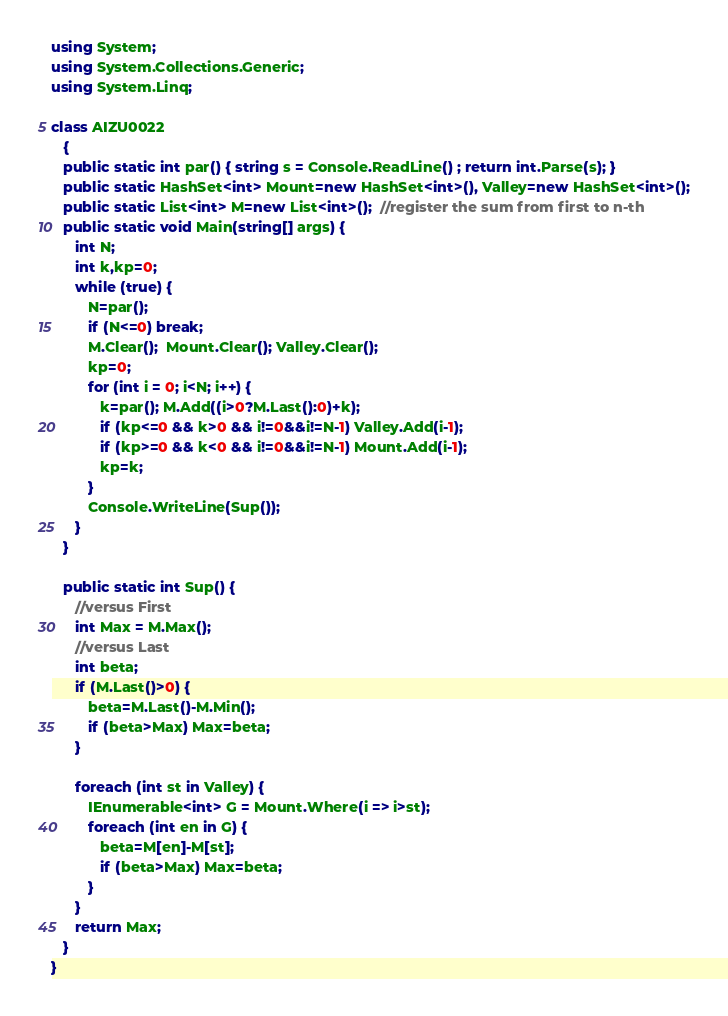<code> <loc_0><loc_0><loc_500><loc_500><_C#_>using System;
using System.Collections.Generic;
using System.Linq;

class AIZU0022
   {
   public static int par() { string s = Console.ReadLine() ; return int.Parse(s); }
   public static HashSet<int> Mount=new HashSet<int>(), Valley=new HashSet<int>();
   public static List<int> M=new List<int>();  //register the sum from first to n-th
   public static void Main(string[] args) {
      int N;
      int k,kp=0;
      while (true) {
         N=par();
         if (N<=0) break;
         M.Clear();  Mount.Clear(); Valley.Clear();
         kp=0;
         for (int i = 0; i<N; i++) {
            k=par(); M.Add((i>0?M.Last():0)+k);
            if (kp<=0 && k>0 && i!=0&&i!=N-1) Valley.Add(i-1);
            if (kp>=0 && k<0 && i!=0&&i!=N-1) Mount.Add(i-1);
            kp=k;
         }
         Console.WriteLine(Sup());
      }
   }

   public static int Sup() { 
      //versus First
      int Max = M.Max();
      //versus Last
      int beta;
      if (M.Last()>0) {
         beta=M.Last()-M.Min();
         if (beta>Max) Max=beta;
      }

      foreach (int st in Valley) {
         IEnumerable<int> G = Mount.Where(i => i>st);
         foreach (int en in G) {
            beta=M[en]-M[st];
            if (beta>Max) Max=beta;
         }
      }
      return Max;
   }
}</code> 